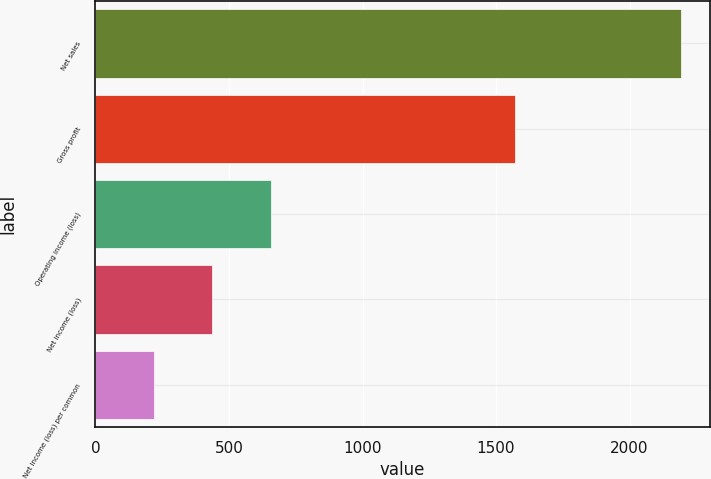Convert chart. <chart><loc_0><loc_0><loc_500><loc_500><bar_chart><fcel>Net sales<fcel>Gross profit<fcel>Operating income (loss)<fcel>Net income (loss)<fcel>Net income (loss) per common<nl><fcel>2191<fcel>1572<fcel>657.36<fcel>438.27<fcel>219.18<nl></chart> 